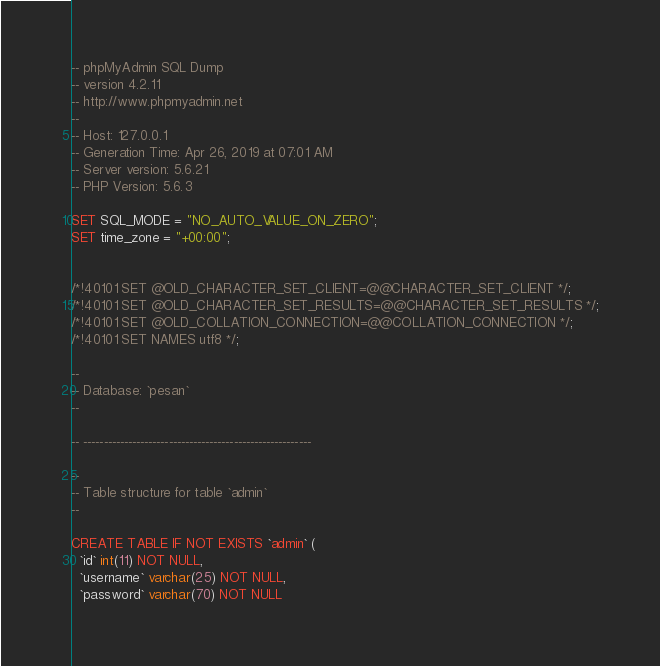<code> <loc_0><loc_0><loc_500><loc_500><_SQL_>-- phpMyAdmin SQL Dump
-- version 4.2.11
-- http://www.phpmyadmin.net
--
-- Host: 127.0.0.1
-- Generation Time: Apr 26, 2019 at 07:01 AM
-- Server version: 5.6.21
-- PHP Version: 5.6.3

SET SQL_MODE = "NO_AUTO_VALUE_ON_ZERO";
SET time_zone = "+00:00";


/*!40101 SET @OLD_CHARACTER_SET_CLIENT=@@CHARACTER_SET_CLIENT */;
/*!40101 SET @OLD_CHARACTER_SET_RESULTS=@@CHARACTER_SET_RESULTS */;
/*!40101 SET @OLD_COLLATION_CONNECTION=@@COLLATION_CONNECTION */;
/*!40101 SET NAMES utf8 */;

--
-- Database: `pesan`
--

-- --------------------------------------------------------

--
-- Table structure for table `admin`
--

CREATE TABLE IF NOT EXISTS `admin` (
  `id` int(11) NOT NULL,
  `username` varchar(25) NOT NULL,
  `password` varchar(70) NOT NULL</code> 